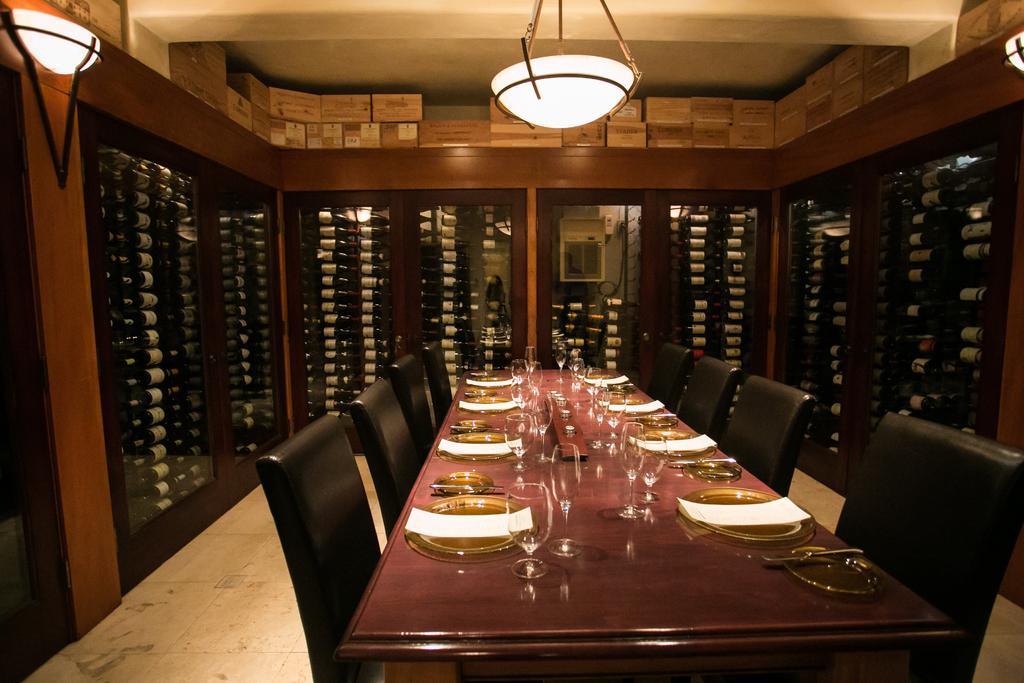Could you give a brief overview of what you see in this image? This picture is taken inside the room. In this image, in the middle, we can see a table and chairs. On the table, we can see some glasses, plates, tissues. On the right side, we can see a window. On the left side, we can also see a window. In the background, we can see a window and some electronic instrument. At the top, we can see some boxes and roof with few lights. 